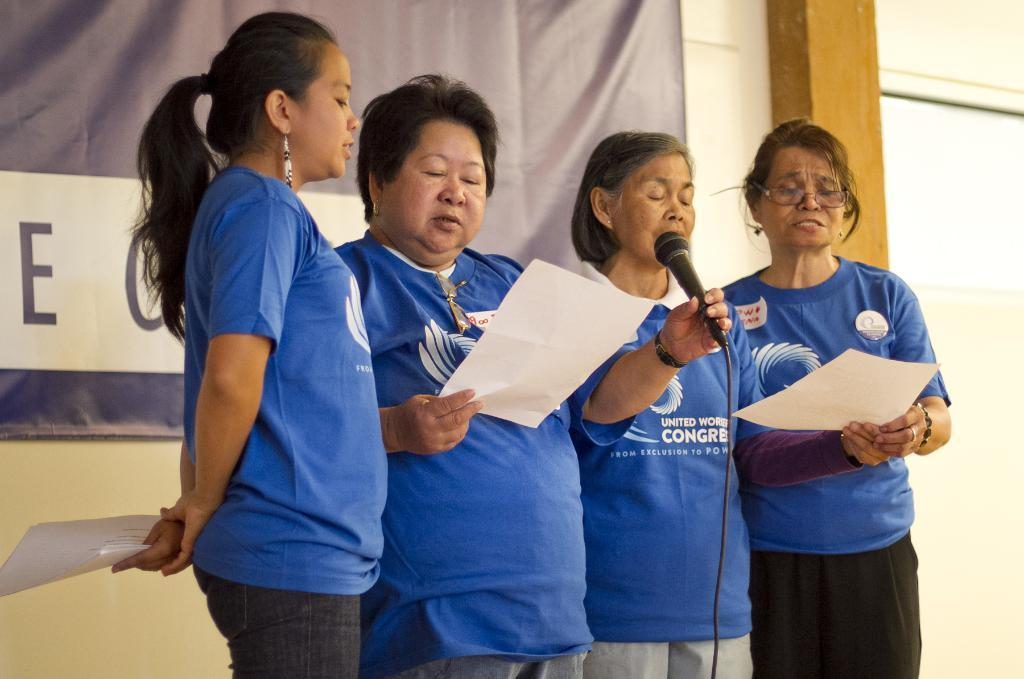How many people are present in the image? There are four people standing in the image. What are the people holding in their hands? The people are holding papers in their hands. Can you identify any specific object held by one of the people? Yes, one person is holding a microphone. What can be seen in the background of the image? There is a poster with text on it in the background. How many cherries are on the engine of the airplane in the image? There is no airplane or cherries present in the image. 